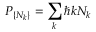<formula> <loc_0><loc_0><loc_500><loc_500>P _ { \{ N _ { k } \} } = \sum _ { k } \hbar { k } N _ { k }</formula> 